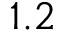Convert formula to latex. <formula><loc_0><loc_0><loc_500><loc_500>1 . 2</formula> 